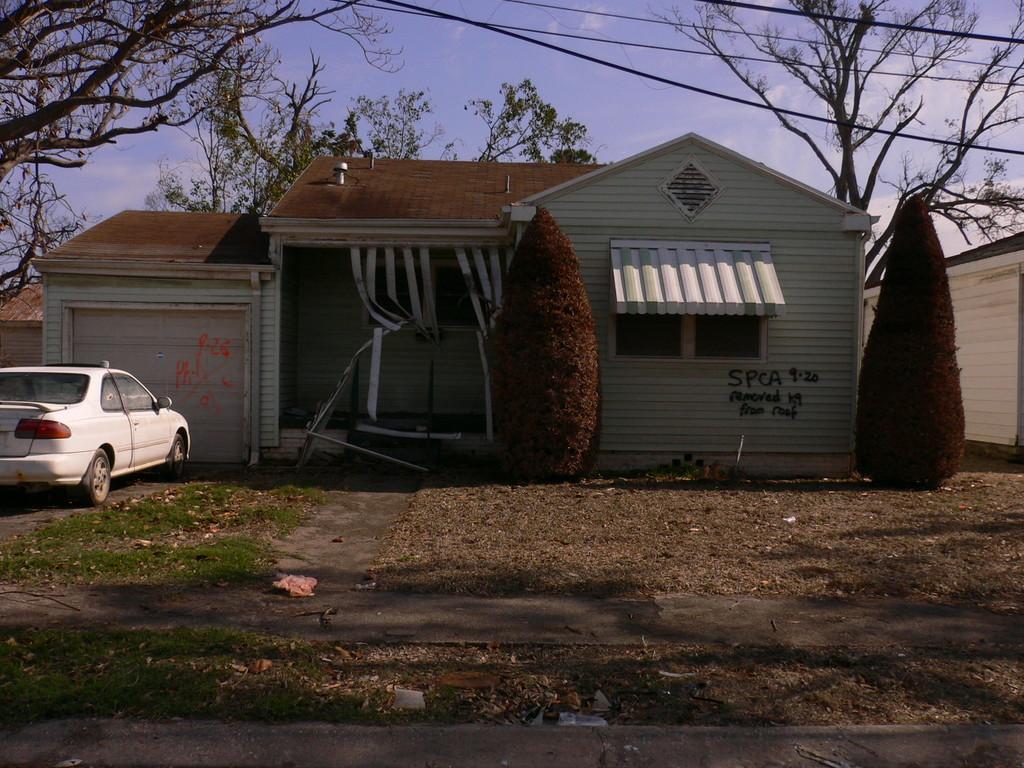In one or two sentences, can you explain what this image depicts? In the picture I can see a house in the middle of the image. I can see a car on the left side. There are trees on the left side and the right side as well. I can see the electric wires at the top of the image. There are clouds in the sky. 